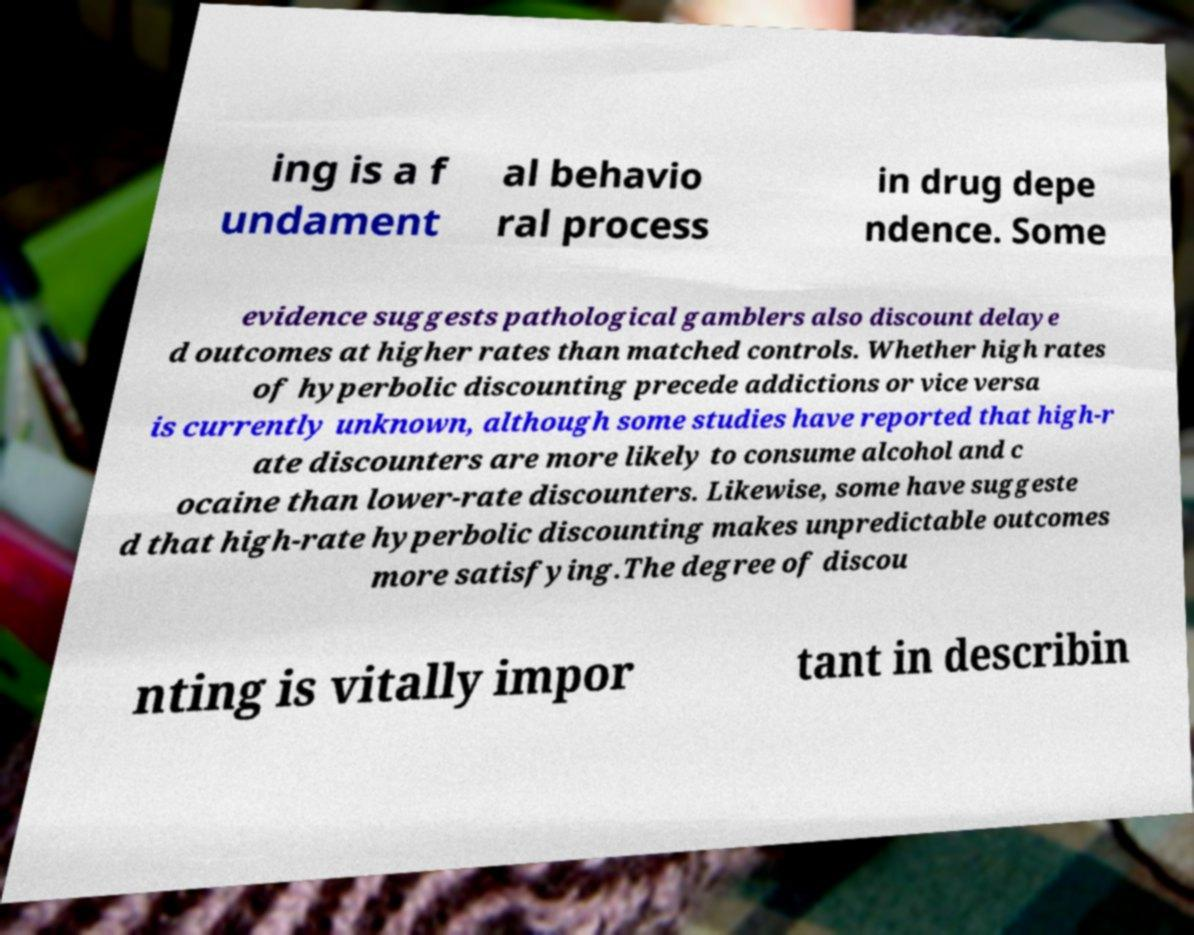There's text embedded in this image that I need extracted. Can you transcribe it verbatim? ing is a f undament al behavio ral process in drug depe ndence. Some evidence suggests pathological gamblers also discount delaye d outcomes at higher rates than matched controls. Whether high rates of hyperbolic discounting precede addictions or vice versa is currently unknown, although some studies have reported that high-r ate discounters are more likely to consume alcohol and c ocaine than lower-rate discounters. Likewise, some have suggeste d that high-rate hyperbolic discounting makes unpredictable outcomes more satisfying.The degree of discou nting is vitally impor tant in describin 